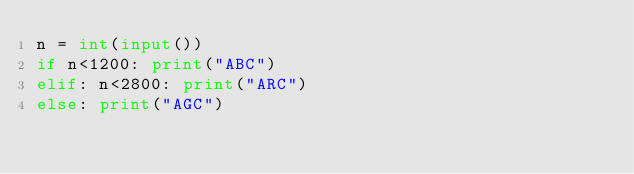<code> <loc_0><loc_0><loc_500><loc_500><_Python_>n = int(input())
if n<1200: print("ABC")
elif: n<2800: print("ARC")
else: print("AGC")</code> 